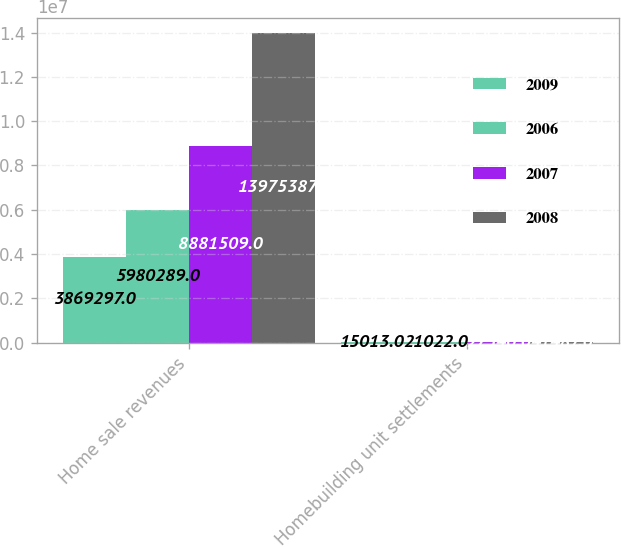Convert chart. <chart><loc_0><loc_0><loc_500><loc_500><stacked_bar_chart><ecel><fcel>Home sale revenues<fcel>Homebuilding unit settlements<nl><fcel>2009<fcel>3.8693e+06<fcel>15013<nl><fcel>2006<fcel>5.98029e+06<fcel>21022<nl><fcel>2007<fcel>8.88151e+06<fcel>27540<nl><fcel>2008<fcel>1.39754e+07<fcel>41487<nl></chart> 